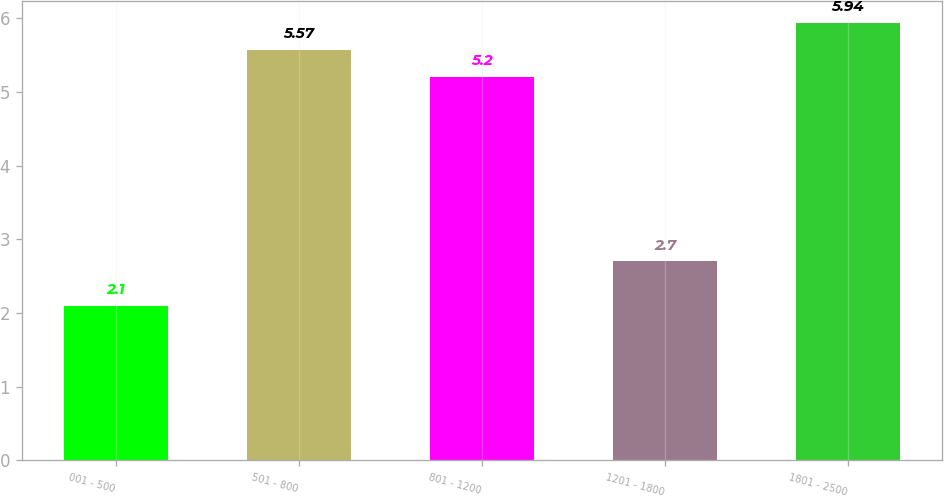<chart> <loc_0><loc_0><loc_500><loc_500><bar_chart><fcel>001 - 500<fcel>501 - 800<fcel>801 - 1200<fcel>1201 - 1800<fcel>1801 - 2500<nl><fcel>2.1<fcel>5.57<fcel>5.2<fcel>2.7<fcel>5.94<nl></chart> 